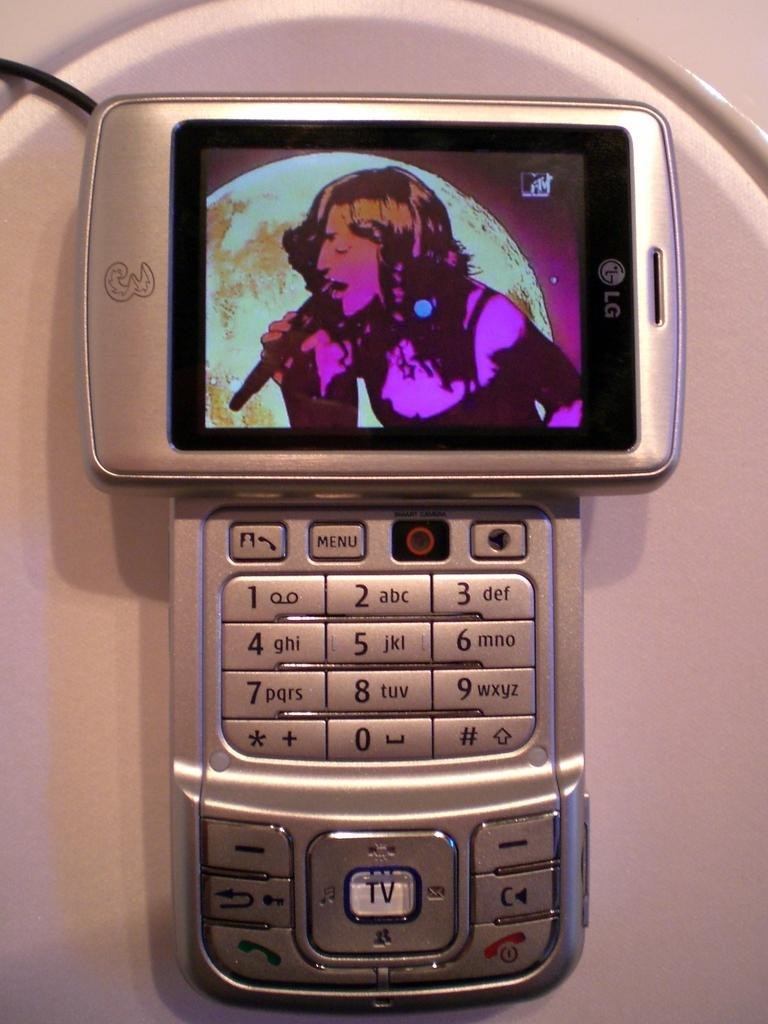<image>
Relay a brief, clear account of the picture shown. A silver cell phone that says LG has a singer on the screen. 